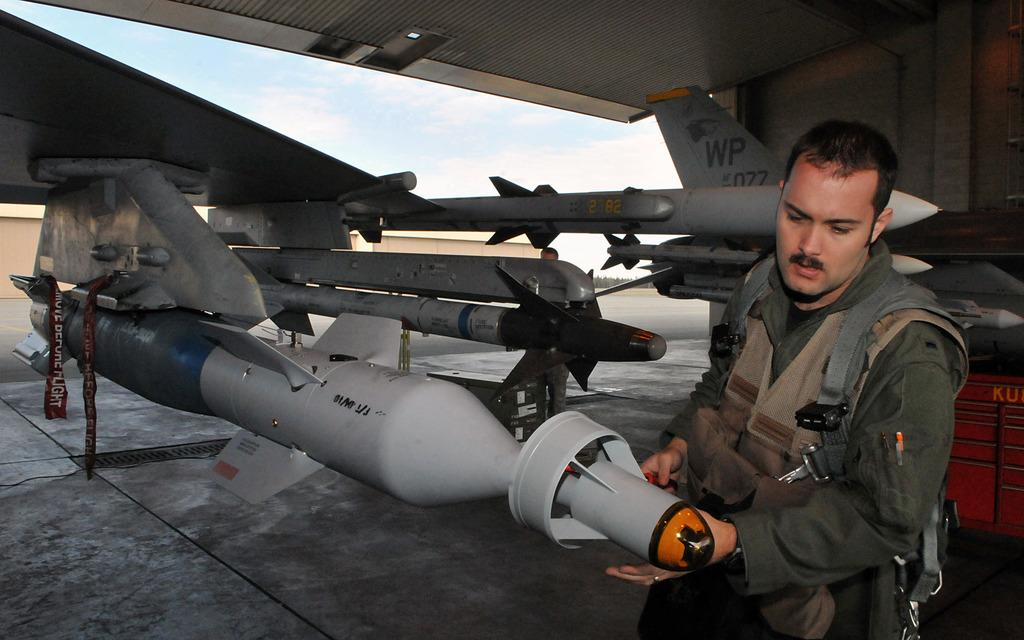<image>
Write a terse but informative summary of the picture. Man looking at a missile on a jet with the plate WP077. 